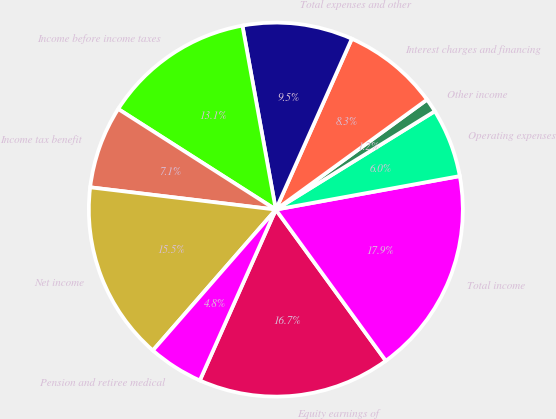Convert chart. <chart><loc_0><loc_0><loc_500><loc_500><pie_chart><fcel>Equity earnings of<fcel>Total income<fcel>Operating expenses<fcel>Other income<fcel>Interest charges and financing<fcel>Total expenses and other<fcel>Income before income taxes<fcel>Income tax benefit<fcel>Net income<fcel>Pension and retiree medical<nl><fcel>16.67%<fcel>17.86%<fcel>5.95%<fcel>1.19%<fcel>8.33%<fcel>9.52%<fcel>13.1%<fcel>7.14%<fcel>15.48%<fcel>4.76%<nl></chart> 